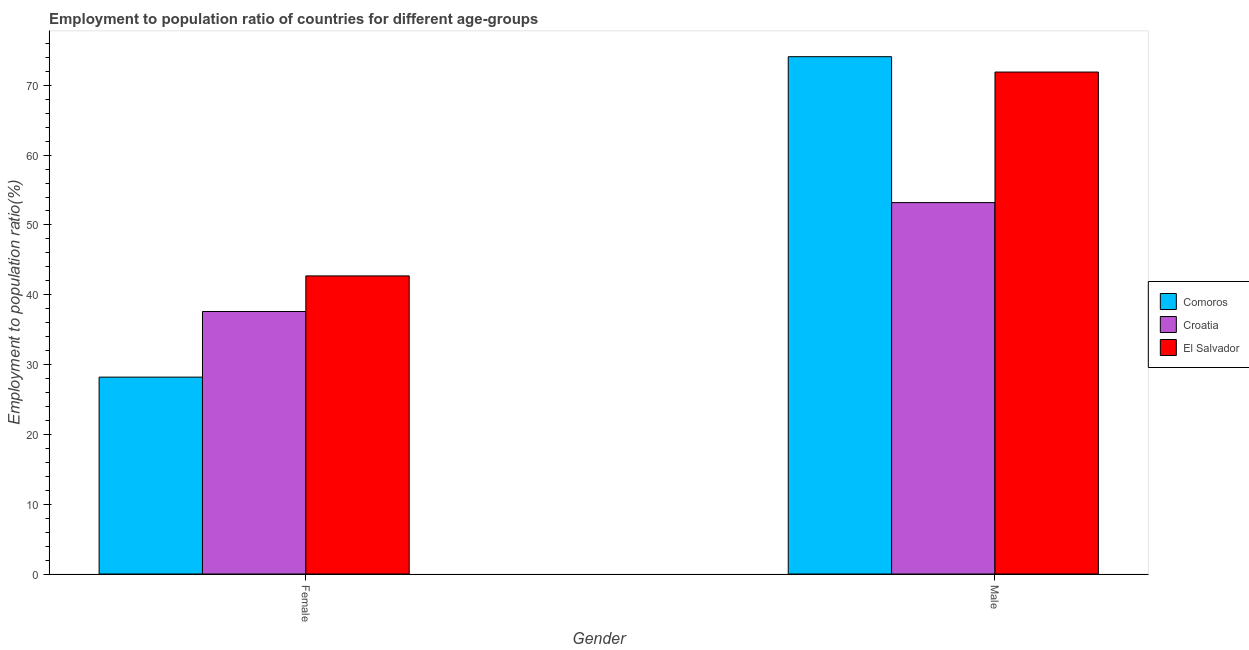Are the number of bars per tick equal to the number of legend labels?
Your answer should be compact. Yes. How many bars are there on the 1st tick from the right?
Your response must be concise. 3. What is the employment to population ratio(male) in Comoros?
Provide a short and direct response. 74.1. Across all countries, what is the maximum employment to population ratio(female)?
Your answer should be very brief. 42.7. Across all countries, what is the minimum employment to population ratio(female)?
Make the answer very short. 28.2. In which country was the employment to population ratio(male) maximum?
Offer a terse response. Comoros. In which country was the employment to population ratio(male) minimum?
Provide a short and direct response. Croatia. What is the total employment to population ratio(male) in the graph?
Your response must be concise. 199.2. What is the difference between the employment to population ratio(male) in El Salvador and that in Croatia?
Keep it short and to the point. 18.7. What is the difference between the employment to population ratio(male) in Comoros and the employment to population ratio(female) in Croatia?
Your answer should be very brief. 36.5. What is the average employment to population ratio(male) per country?
Provide a short and direct response. 66.4. What is the difference between the employment to population ratio(female) and employment to population ratio(male) in Comoros?
Ensure brevity in your answer.  -45.9. What is the ratio of the employment to population ratio(female) in Croatia to that in El Salvador?
Your answer should be compact. 0.88. What does the 2nd bar from the left in Female represents?
Make the answer very short. Croatia. What does the 2nd bar from the right in Female represents?
Keep it short and to the point. Croatia. Are all the bars in the graph horizontal?
Your answer should be compact. No. What is the difference between two consecutive major ticks on the Y-axis?
Give a very brief answer. 10. Does the graph contain any zero values?
Your response must be concise. No. Where does the legend appear in the graph?
Ensure brevity in your answer.  Center right. How many legend labels are there?
Provide a short and direct response. 3. How are the legend labels stacked?
Ensure brevity in your answer.  Vertical. What is the title of the graph?
Your answer should be very brief. Employment to population ratio of countries for different age-groups. What is the label or title of the X-axis?
Give a very brief answer. Gender. What is the Employment to population ratio(%) in Comoros in Female?
Your answer should be compact. 28.2. What is the Employment to population ratio(%) of Croatia in Female?
Ensure brevity in your answer.  37.6. What is the Employment to population ratio(%) in El Salvador in Female?
Offer a very short reply. 42.7. What is the Employment to population ratio(%) of Comoros in Male?
Your answer should be compact. 74.1. What is the Employment to population ratio(%) in Croatia in Male?
Your answer should be very brief. 53.2. What is the Employment to population ratio(%) in El Salvador in Male?
Provide a succinct answer. 71.9. Across all Gender, what is the maximum Employment to population ratio(%) of Comoros?
Your response must be concise. 74.1. Across all Gender, what is the maximum Employment to population ratio(%) in Croatia?
Offer a terse response. 53.2. Across all Gender, what is the maximum Employment to population ratio(%) of El Salvador?
Your answer should be very brief. 71.9. Across all Gender, what is the minimum Employment to population ratio(%) in Comoros?
Give a very brief answer. 28.2. Across all Gender, what is the minimum Employment to population ratio(%) of Croatia?
Your answer should be compact. 37.6. Across all Gender, what is the minimum Employment to population ratio(%) of El Salvador?
Ensure brevity in your answer.  42.7. What is the total Employment to population ratio(%) in Comoros in the graph?
Give a very brief answer. 102.3. What is the total Employment to population ratio(%) of Croatia in the graph?
Provide a succinct answer. 90.8. What is the total Employment to population ratio(%) in El Salvador in the graph?
Keep it short and to the point. 114.6. What is the difference between the Employment to population ratio(%) in Comoros in Female and that in Male?
Provide a short and direct response. -45.9. What is the difference between the Employment to population ratio(%) in Croatia in Female and that in Male?
Your response must be concise. -15.6. What is the difference between the Employment to population ratio(%) of El Salvador in Female and that in Male?
Your answer should be very brief. -29.2. What is the difference between the Employment to population ratio(%) of Comoros in Female and the Employment to population ratio(%) of Croatia in Male?
Your answer should be compact. -25. What is the difference between the Employment to population ratio(%) in Comoros in Female and the Employment to population ratio(%) in El Salvador in Male?
Ensure brevity in your answer.  -43.7. What is the difference between the Employment to population ratio(%) in Croatia in Female and the Employment to population ratio(%) in El Salvador in Male?
Keep it short and to the point. -34.3. What is the average Employment to population ratio(%) of Comoros per Gender?
Your response must be concise. 51.15. What is the average Employment to population ratio(%) in Croatia per Gender?
Provide a short and direct response. 45.4. What is the average Employment to population ratio(%) in El Salvador per Gender?
Your answer should be very brief. 57.3. What is the difference between the Employment to population ratio(%) of Comoros and Employment to population ratio(%) of Croatia in Male?
Offer a terse response. 20.9. What is the difference between the Employment to population ratio(%) of Comoros and Employment to population ratio(%) of El Salvador in Male?
Offer a very short reply. 2.2. What is the difference between the Employment to population ratio(%) in Croatia and Employment to population ratio(%) in El Salvador in Male?
Provide a succinct answer. -18.7. What is the ratio of the Employment to population ratio(%) of Comoros in Female to that in Male?
Give a very brief answer. 0.38. What is the ratio of the Employment to population ratio(%) in Croatia in Female to that in Male?
Make the answer very short. 0.71. What is the ratio of the Employment to population ratio(%) of El Salvador in Female to that in Male?
Offer a very short reply. 0.59. What is the difference between the highest and the second highest Employment to population ratio(%) in Comoros?
Your answer should be very brief. 45.9. What is the difference between the highest and the second highest Employment to population ratio(%) in El Salvador?
Offer a very short reply. 29.2. What is the difference between the highest and the lowest Employment to population ratio(%) of Comoros?
Your response must be concise. 45.9. What is the difference between the highest and the lowest Employment to population ratio(%) of Croatia?
Give a very brief answer. 15.6. What is the difference between the highest and the lowest Employment to population ratio(%) of El Salvador?
Ensure brevity in your answer.  29.2. 